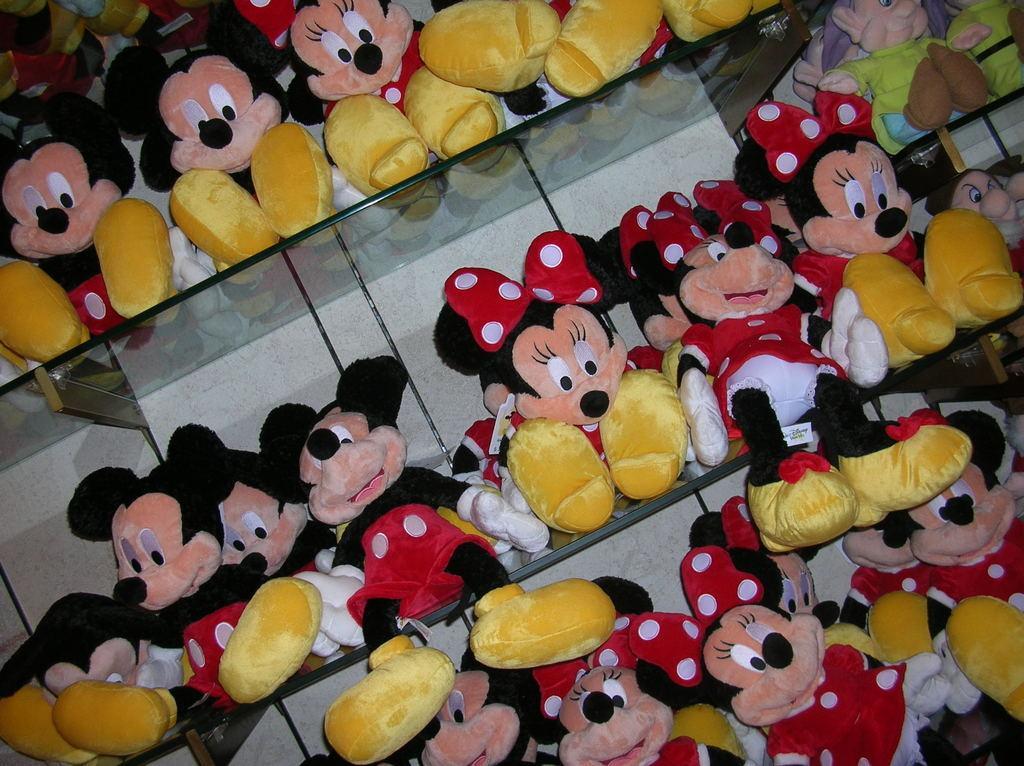In one or two sentences, can you explain what this image depicts? This image consists of shelves. There are so many dolls of Mickey mouses. 